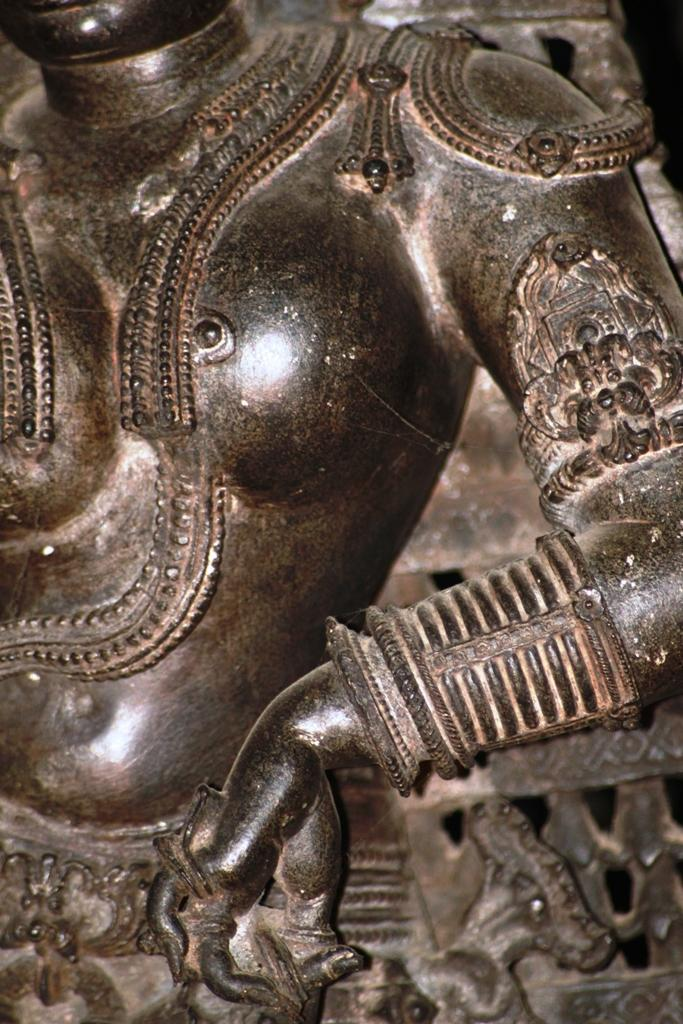What is the main subject in the image? There is a statue of a woman in the image. What is located behind the statue? There is a brick wall behind the statue. What type of camera is the statue holding in the image? There is no camera present in the image; the statue is not holding anything. 